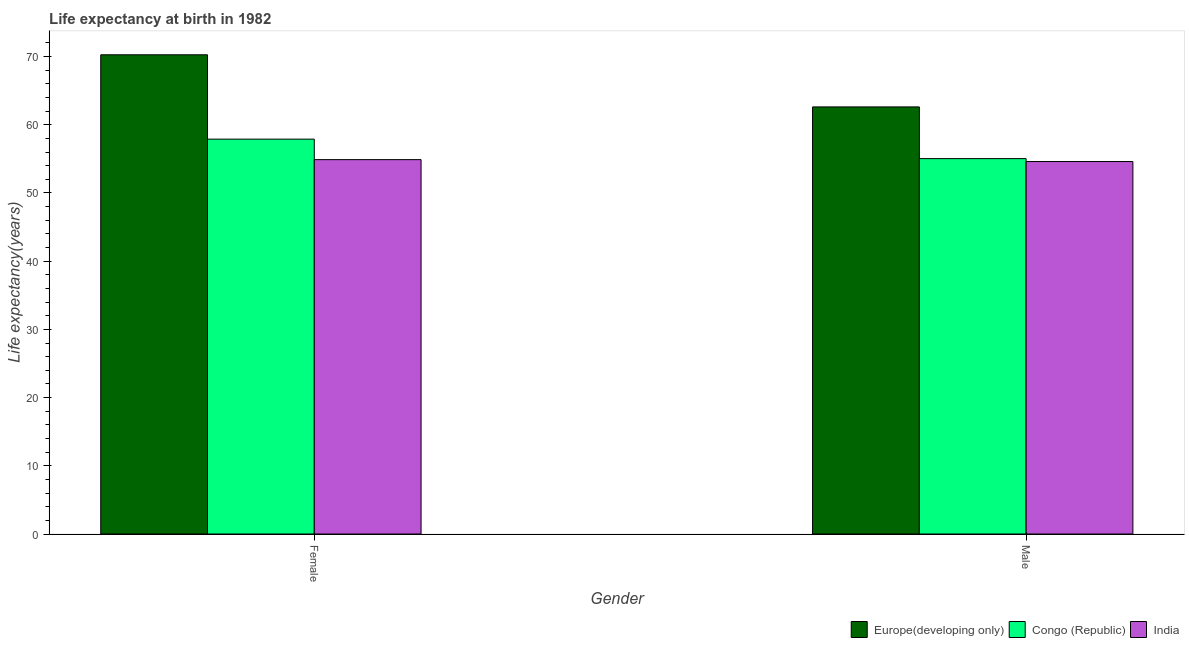How many different coloured bars are there?
Offer a very short reply. 3. How many groups of bars are there?
Provide a succinct answer. 2. Are the number of bars per tick equal to the number of legend labels?
Your answer should be very brief. Yes. How many bars are there on the 1st tick from the left?
Make the answer very short. 3. What is the label of the 2nd group of bars from the left?
Your response must be concise. Male. What is the life expectancy(female) in India?
Your response must be concise. 54.89. Across all countries, what is the maximum life expectancy(male)?
Provide a succinct answer. 62.62. Across all countries, what is the minimum life expectancy(male)?
Your answer should be compact. 54.61. In which country was the life expectancy(male) maximum?
Provide a short and direct response. Europe(developing only). In which country was the life expectancy(female) minimum?
Provide a succinct answer. India. What is the total life expectancy(female) in the graph?
Ensure brevity in your answer.  183.04. What is the difference between the life expectancy(female) in Congo (Republic) and that in India?
Provide a succinct answer. 3.01. What is the difference between the life expectancy(female) in Europe(developing only) and the life expectancy(male) in India?
Ensure brevity in your answer.  15.65. What is the average life expectancy(male) per country?
Keep it short and to the point. 57.42. What is the difference between the life expectancy(female) and life expectancy(male) in Congo (Republic)?
Provide a succinct answer. 2.86. In how many countries, is the life expectancy(female) greater than 68 years?
Your answer should be compact. 1. What is the ratio of the life expectancy(male) in Europe(developing only) to that in India?
Your answer should be compact. 1.15. Is the life expectancy(male) in India less than that in Europe(developing only)?
Provide a succinct answer. Yes. What does the 1st bar from the left in Female represents?
Offer a terse response. Europe(developing only). What does the 3rd bar from the right in Male represents?
Your answer should be very brief. Europe(developing only). How many bars are there?
Your answer should be compact. 6. Are all the bars in the graph horizontal?
Give a very brief answer. No. How many countries are there in the graph?
Your answer should be very brief. 3. Does the graph contain any zero values?
Offer a terse response. No. How are the legend labels stacked?
Offer a very short reply. Horizontal. What is the title of the graph?
Your answer should be compact. Life expectancy at birth in 1982. Does "Kazakhstan" appear as one of the legend labels in the graph?
Offer a very short reply. No. What is the label or title of the X-axis?
Your answer should be very brief. Gender. What is the label or title of the Y-axis?
Provide a succinct answer. Life expectancy(years). What is the Life expectancy(years) in Europe(developing only) in Female?
Your answer should be compact. 70.26. What is the Life expectancy(years) of Congo (Republic) in Female?
Provide a succinct answer. 57.89. What is the Life expectancy(years) of India in Female?
Your answer should be very brief. 54.89. What is the Life expectancy(years) in Europe(developing only) in Male?
Make the answer very short. 62.62. What is the Life expectancy(years) of Congo (Republic) in Male?
Provide a short and direct response. 55.04. What is the Life expectancy(years) in India in Male?
Give a very brief answer. 54.61. Across all Gender, what is the maximum Life expectancy(years) in Europe(developing only)?
Provide a short and direct response. 70.26. Across all Gender, what is the maximum Life expectancy(years) in Congo (Republic)?
Make the answer very short. 57.89. Across all Gender, what is the maximum Life expectancy(years) in India?
Your answer should be very brief. 54.89. Across all Gender, what is the minimum Life expectancy(years) in Europe(developing only)?
Give a very brief answer. 62.62. Across all Gender, what is the minimum Life expectancy(years) in Congo (Republic)?
Offer a very short reply. 55.04. Across all Gender, what is the minimum Life expectancy(years) of India?
Offer a terse response. 54.61. What is the total Life expectancy(years) of Europe(developing only) in the graph?
Give a very brief answer. 132.88. What is the total Life expectancy(years) in Congo (Republic) in the graph?
Make the answer very short. 112.93. What is the total Life expectancy(years) in India in the graph?
Offer a very short reply. 109.5. What is the difference between the Life expectancy(years) of Europe(developing only) in Female and that in Male?
Offer a very short reply. 7.64. What is the difference between the Life expectancy(years) in Congo (Republic) in Female and that in Male?
Offer a terse response. 2.86. What is the difference between the Life expectancy(years) of India in Female and that in Male?
Offer a very short reply. 0.28. What is the difference between the Life expectancy(years) of Europe(developing only) in Female and the Life expectancy(years) of Congo (Republic) in Male?
Make the answer very short. 15.22. What is the difference between the Life expectancy(years) of Europe(developing only) in Female and the Life expectancy(years) of India in Male?
Your answer should be very brief. 15.65. What is the difference between the Life expectancy(years) in Congo (Republic) in Female and the Life expectancy(years) in India in Male?
Provide a short and direct response. 3.28. What is the average Life expectancy(years) of Europe(developing only) per Gender?
Give a very brief answer. 66.44. What is the average Life expectancy(years) of Congo (Republic) per Gender?
Offer a terse response. 56.46. What is the average Life expectancy(years) of India per Gender?
Make the answer very short. 54.75. What is the difference between the Life expectancy(years) of Europe(developing only) and Life expectancy(years) of Congo (Republic) in Female?
Keep it short and to the point. 12.37. What is the difference between the Life expectancy(years) of Europe(developing only) and Life expectancy(years) of India in Female?
Offer a very short reply. 15.37. What is the difference between the Life expectancy(years) in Congo (Republic) and Life expectancy(years) in India in Female?
Provide a short and direct response. 3. What is the difference between the Life expectancy(years) in Europe(developing only) and Life expectancy(years) in Congo (Republic) in Male?
Provide a succinct answer. 7.58. What is the difference between the Life expectancy(years) in Europe(developing only) and Life expectancy(years) in India in Male?
Make the answer very short. 8.01. What is the difference between the Life expectancy(years) of Congo (Republic) and Life expectancy(years) of India in Male?
Provide a succinct answer. 0.43. What is the ratio of the Life expectancy(years) in Europe(developing only) in Female to that in Male?
Offer a terse response. 1.12. What is the ratio of the Life expectancy(years) of Congo (Republic) in Female to that in Male?
Keep it short and to the point. 1.05. What is the difference between the highest and the second highest Life expectancy(years) of Europe(developing only)?
Keep it short and to the point. 7.64. What is the difference between the highest and the second highest Life expectancy(years) of Congo (Republic)?
Offer a terse response. 2.86. What is the difference between the highest and the second highest Life expectancy(years) of India?
Give a very brief answer. 0.28. What is the difference between the highest and the lowest Life expectancy(years) in Europe(developing only)?
Make the answer very short. 7.64. What is the difference between the highest and the lowest Life expectancy(years) of Congo (Republic)?
Make the answer very short. 2.86. What is the difference between the highest and the lowest Life expectancy(years) in India?
Offer a very short reply. 0.28. 